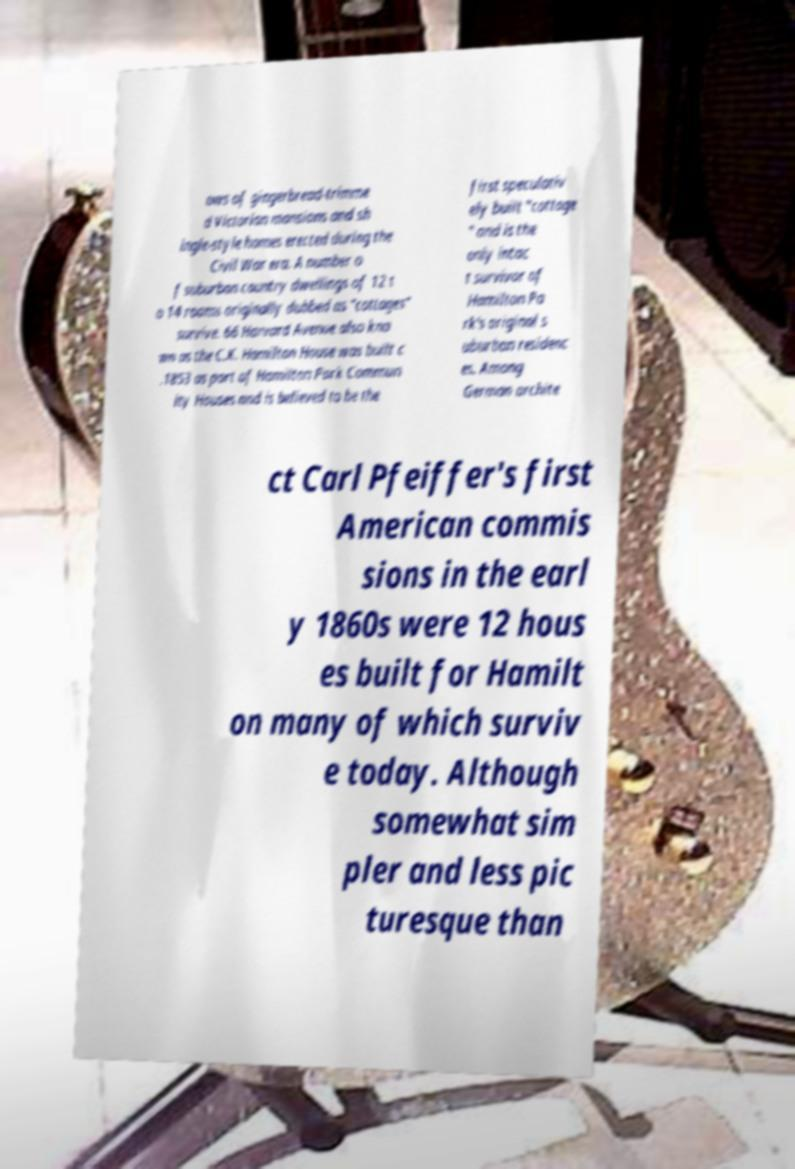Can you accurately transcribe the text from the provided image for me? ows of gingerbread-trimme d Victorian mansions and sh ingle-style homes erected during the Civil War era. A number o f suburban country dwellings of 12 t o 14 rooms originally dubbed as "cottages" survive. 66 Harvard Avenue also kno wn as the C.K. Hamilton House was built c .1853 as part of Hamilton Park Commun ity Houses and is believed to be the first speculativ ely built "cottage " and is the only intac t survivor of Hamilton Pa rk's original s uburban residenc es. Among German archite ct Carl Pfeiffer's first American commis sions in the earl y 1860s were 12 hous es built for Hamilt on many of which surviv e today. Although somewhat sim pler and less pic turesque than 